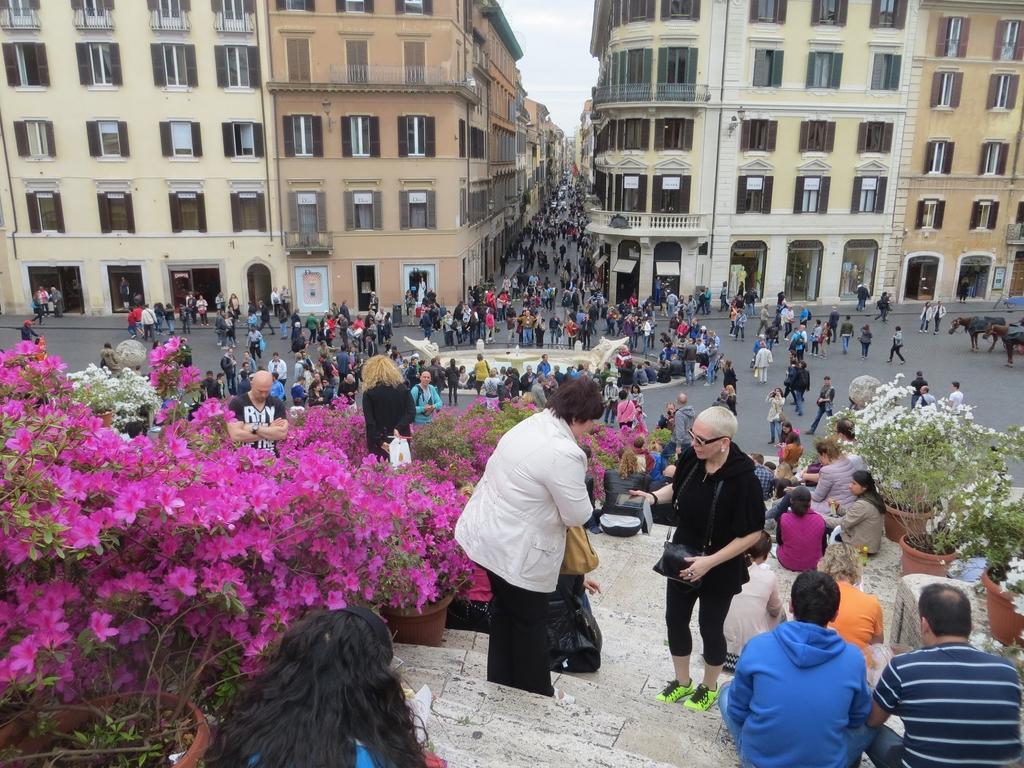Describe this image in one or two sentences. In the image there are few people walking and standing on the road with buildings on either side of it, in the front there are many people sitting on the steps with flower plants on either side of it. 